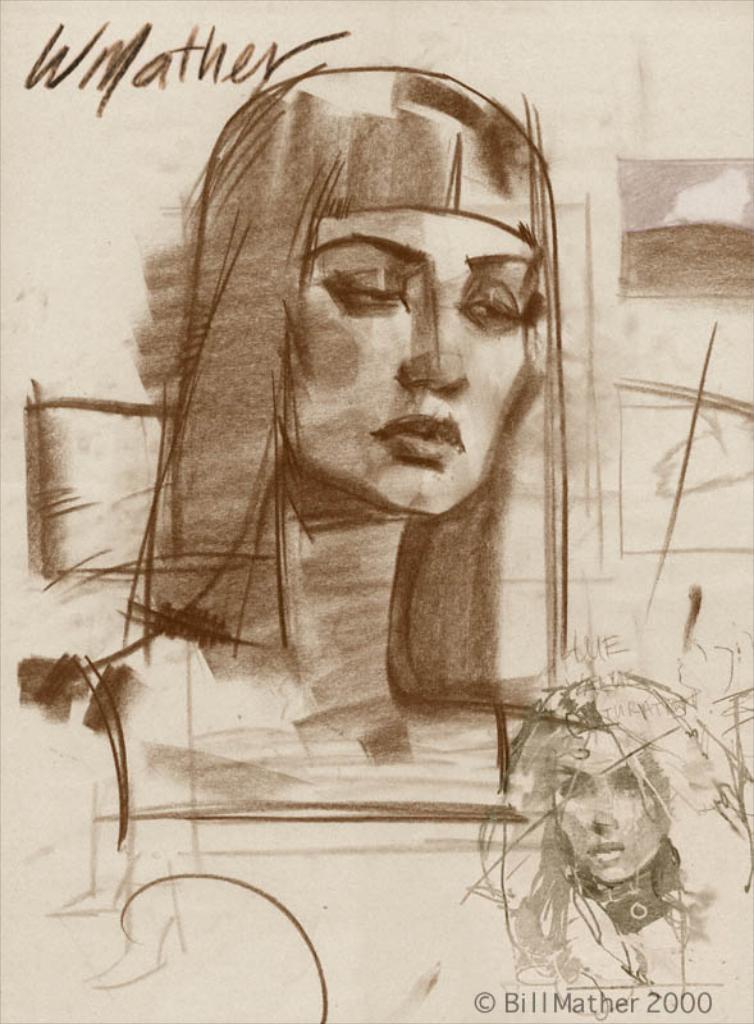Could you give a brief overview of what you see in this image? This picture is an edited picture. In this image there is a sketch of a woman. At the top left there is a text. At the bottom right there is a sketch of a woman and there is a text. 